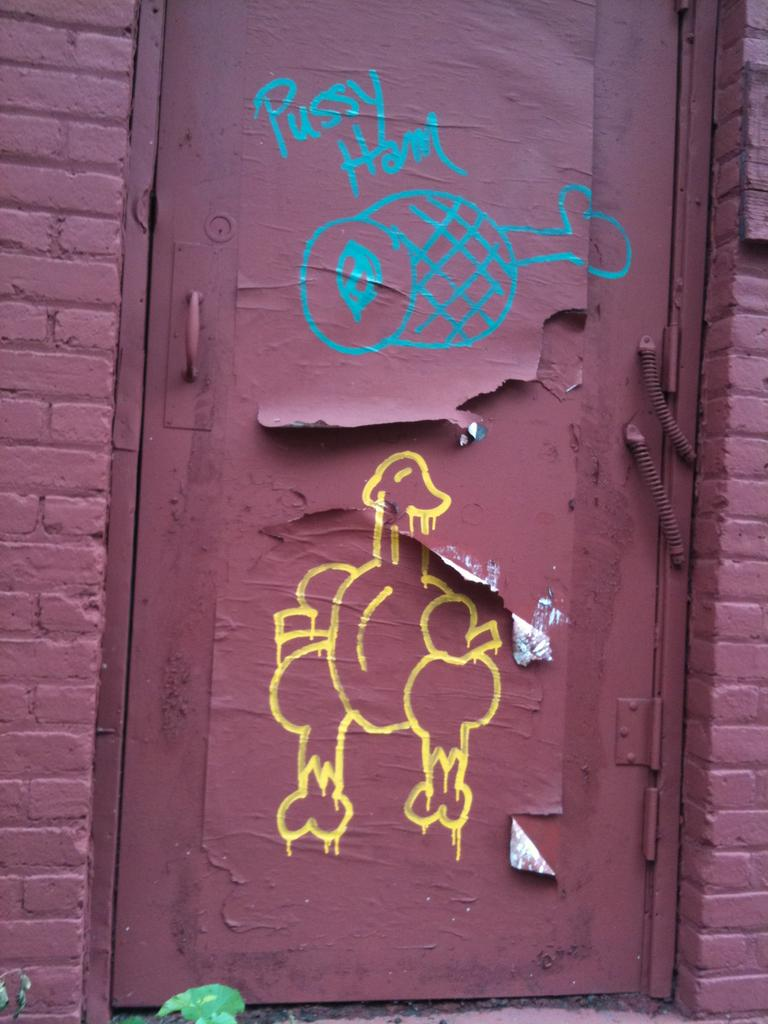What is the main architectural feature in the image? There is a door in the image. What else can be seen around the door? There are two walls surrounding the door in the image. What type of hat is hanging on the door in the image? There is no hat present on the door in the image. 